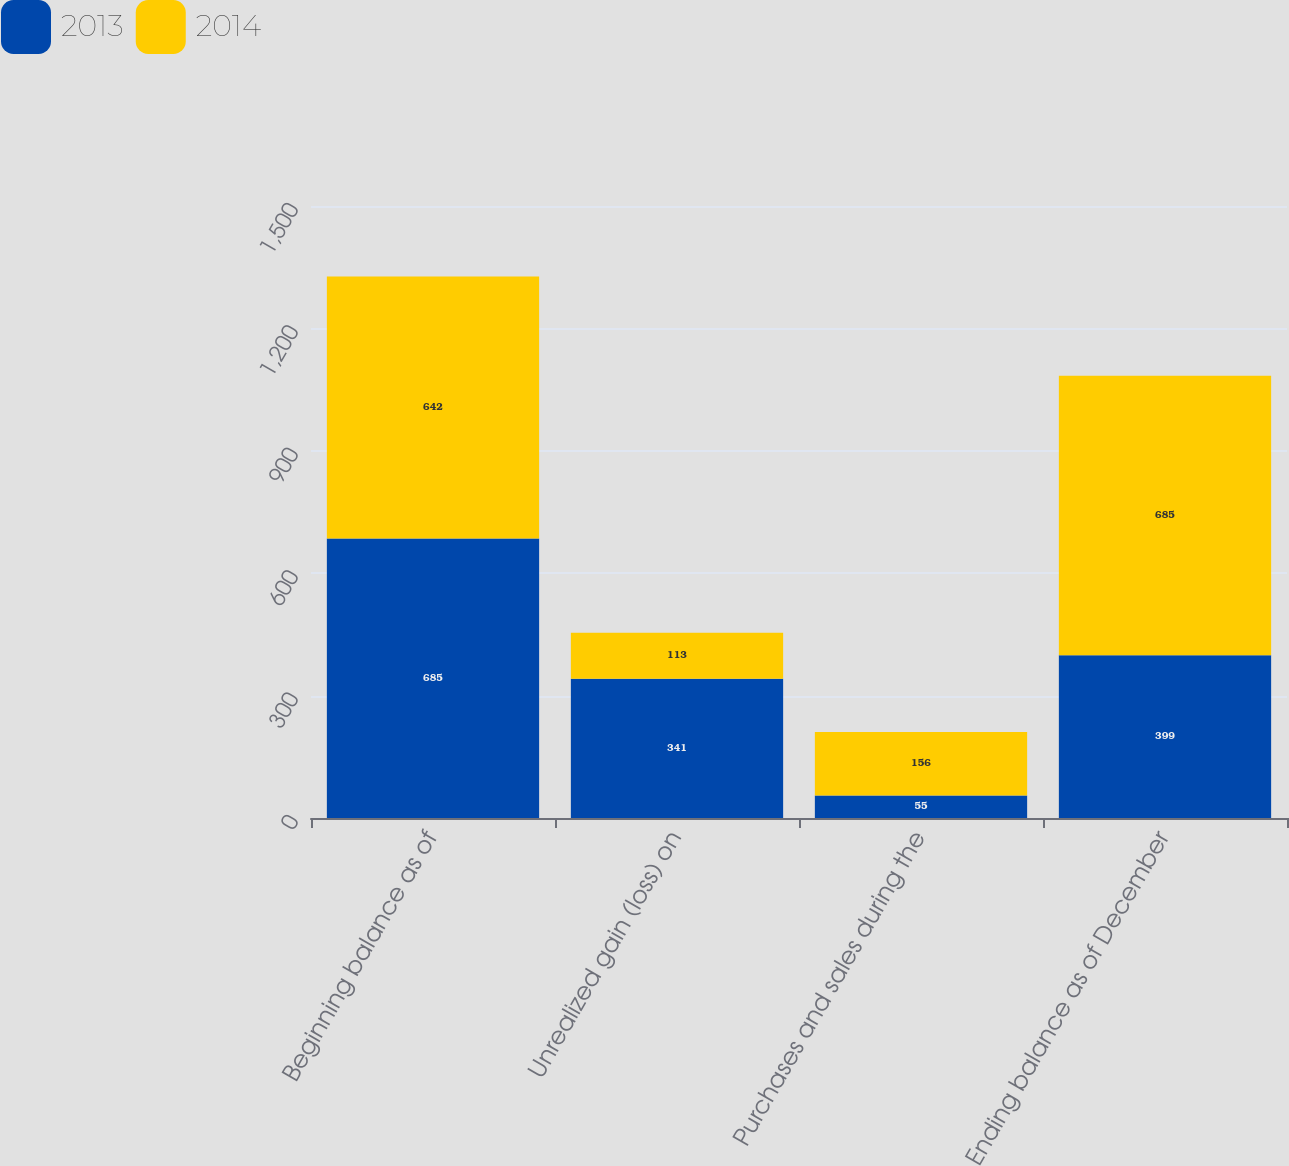Convert chart to OTSL. <chart><loc_0><loc_0><loc_500><loc_500><stacked_bar_chart><ecel><fcel>Beginning balance as of<fcel>Unrealized gain (loss) on<fcel>Purchases and sales during the<fcel>Ending balance as of December<nl><fcel>2013<fcel>685<fcel>341<fcel>55<fcel>399<nl><fcel>2014<fcel>642<fcel>113<fcel>156<fcel>685<nl></chart> 